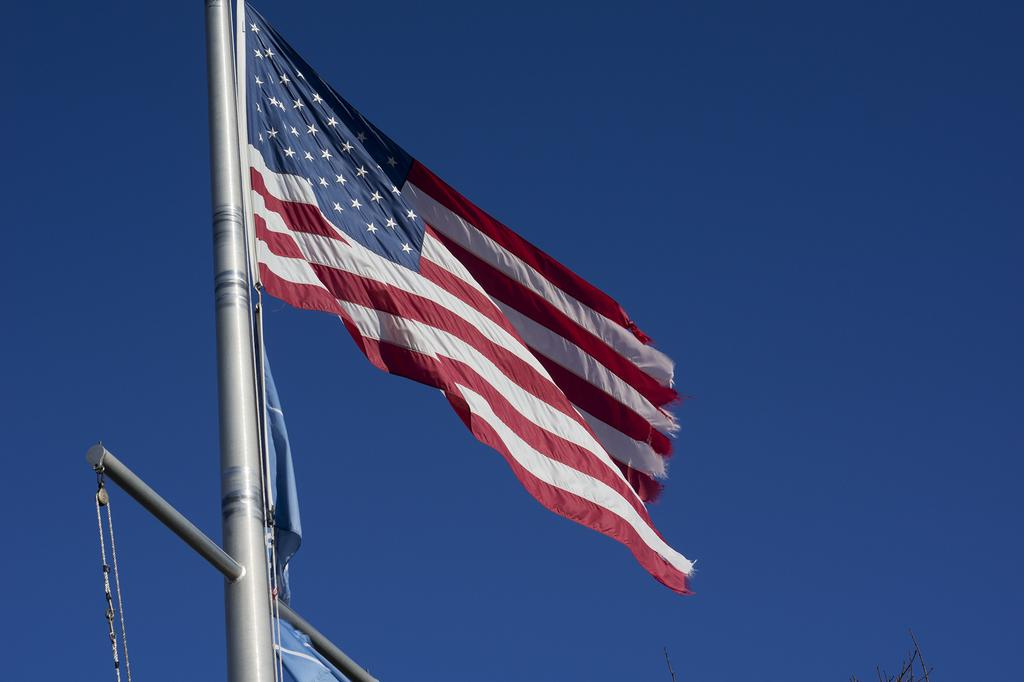What is the main subject of the image? The main subject of the image is an American flag. Where is the American flag located in the image? The American flag is on the left side of the image. What type of feast is being prepared in the image? There is no feast or any indication of food preparation in the image; it only features an American flag. Can you see any spots on the American flag in the image? The image does not show any spots on the American flag; it appears to be clean and well-maintained. 